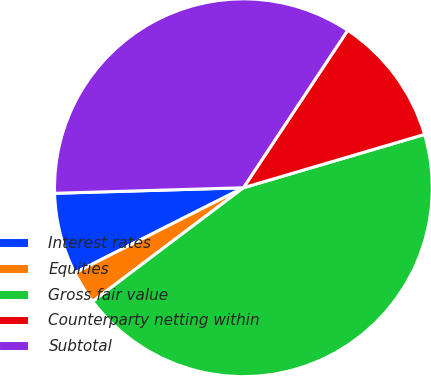<chart> <loc_0><loc_0><loc_500><loc_500><pie_chart><fcel>Interest rates<fcel>Equities<fcel>Gross fair value<fcel>Counterparty netting within<fcel>Subtotal<nl><fcel>6.98%<fcel>2.84%<fcel>44.27%<fcel>11.13%<fcel>34.78%<nl></chart> 